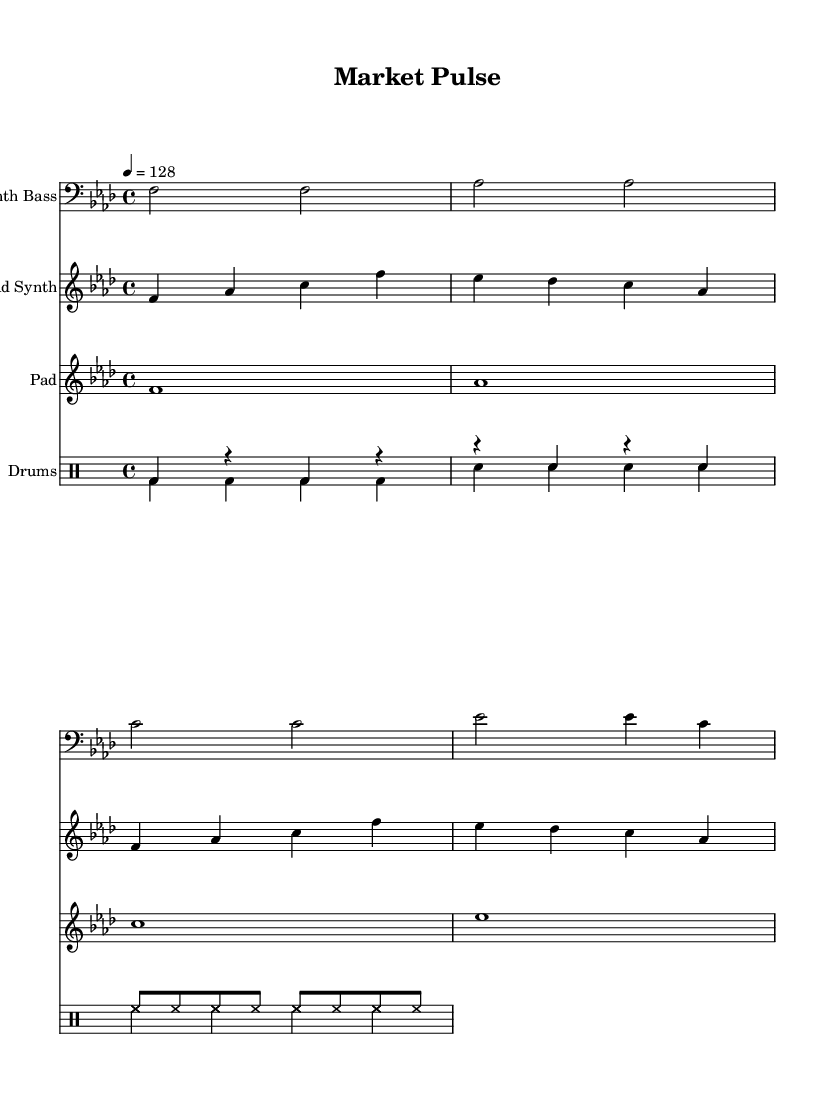What is the key signature of this music? The key signature is F minor, which has four flats (B♭, E♭, A♭, D♭). This can be determined by looking at the key signature indicated at the beginning of the staff.
Answer: F minor What is the time signature of this music? The time signature is 4/4, which means there are four beats in each measure and the quarter note gets one beat. This can be identified by the fraction written at the beginning of the piece.
Answer: 4/4 What is the tempo marking of this piece? The tempo marking is 128 beats per minute, which is specified at the start with the notation "4 = 128". This indicates how many beats occur in one minute of the piece.
Answer: 128 How many measures are in the Lead Synth section? The Lead Synth section contains eight measures. By counting the vertical lines (bar lines) and considering the sections of music presented, we can determine the number of measures.
Answer: 8 What type of drums are present in this piece? The piece features bass drum, snare drum, and hi-hat as indicated by the names within the drum staff. These instruments are commonly used in dance music for their rhythmic qualities.
Answer: Bass drum, snare drum, hi-hat Are there any recurring melodic patterns in the Lead Synth? Yes, the Lead Synth features a recurring melodic phrase, specifically the notes f, aes, c, and ees, which appears throughout the section. This repetition is a common characteristic in dance music to create familiarity.
Answer: Yes How many different voices are used for the drums? There are two different voices used for the drums: one for rhythm and one for pitches. The use of multiple voices allows for a more complex and engaging drum section.
Answer: 2 